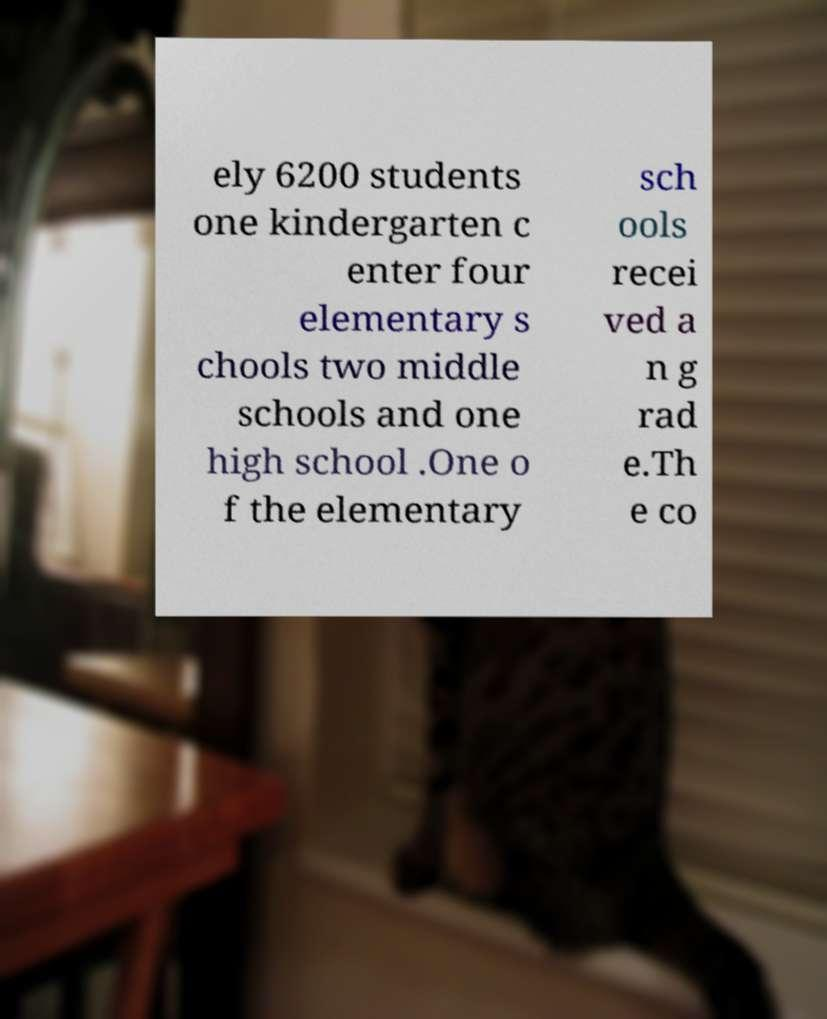Please read and relay the text visible in this image. What does it say? ely 6200 students one kindergarten c enter four elementary s chools two middle schools and one high school .One o f the elementary sch ools recei ved a n g rad e.Th e co 